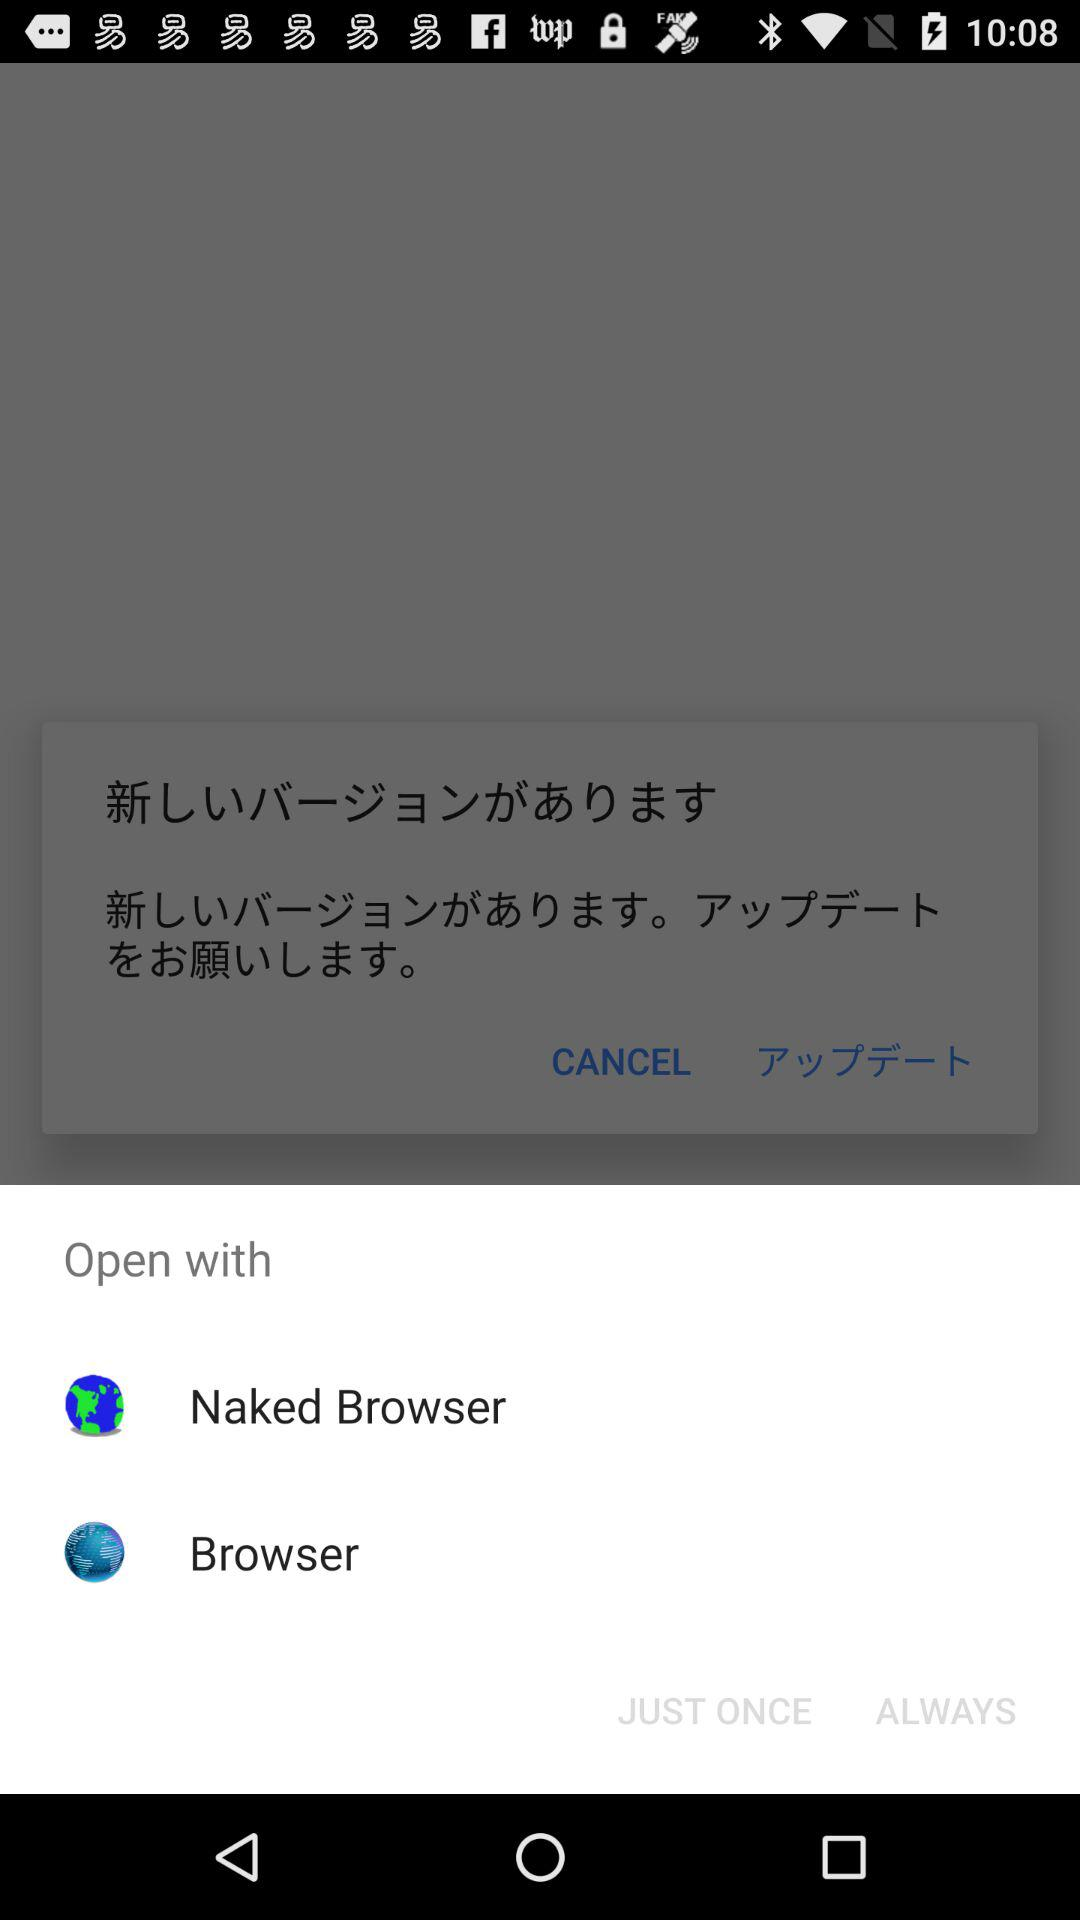What are the different browser applications that can be used to open the content? The application that can be used to open the content is "Naked Browser". 